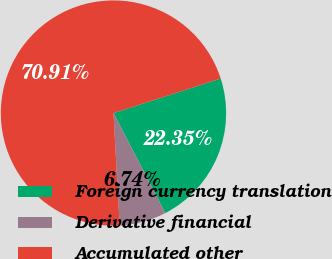Convert chart. <chart><loc_0><loc_0><loc_500><loc_500><pie_chart><fcel>Foreign currency translation<fcel>Derivative financial<fcel>Accumulated other<nl><fcel>22.35%<fcel>6.74%<fcel>70.91%<nl></chart> 